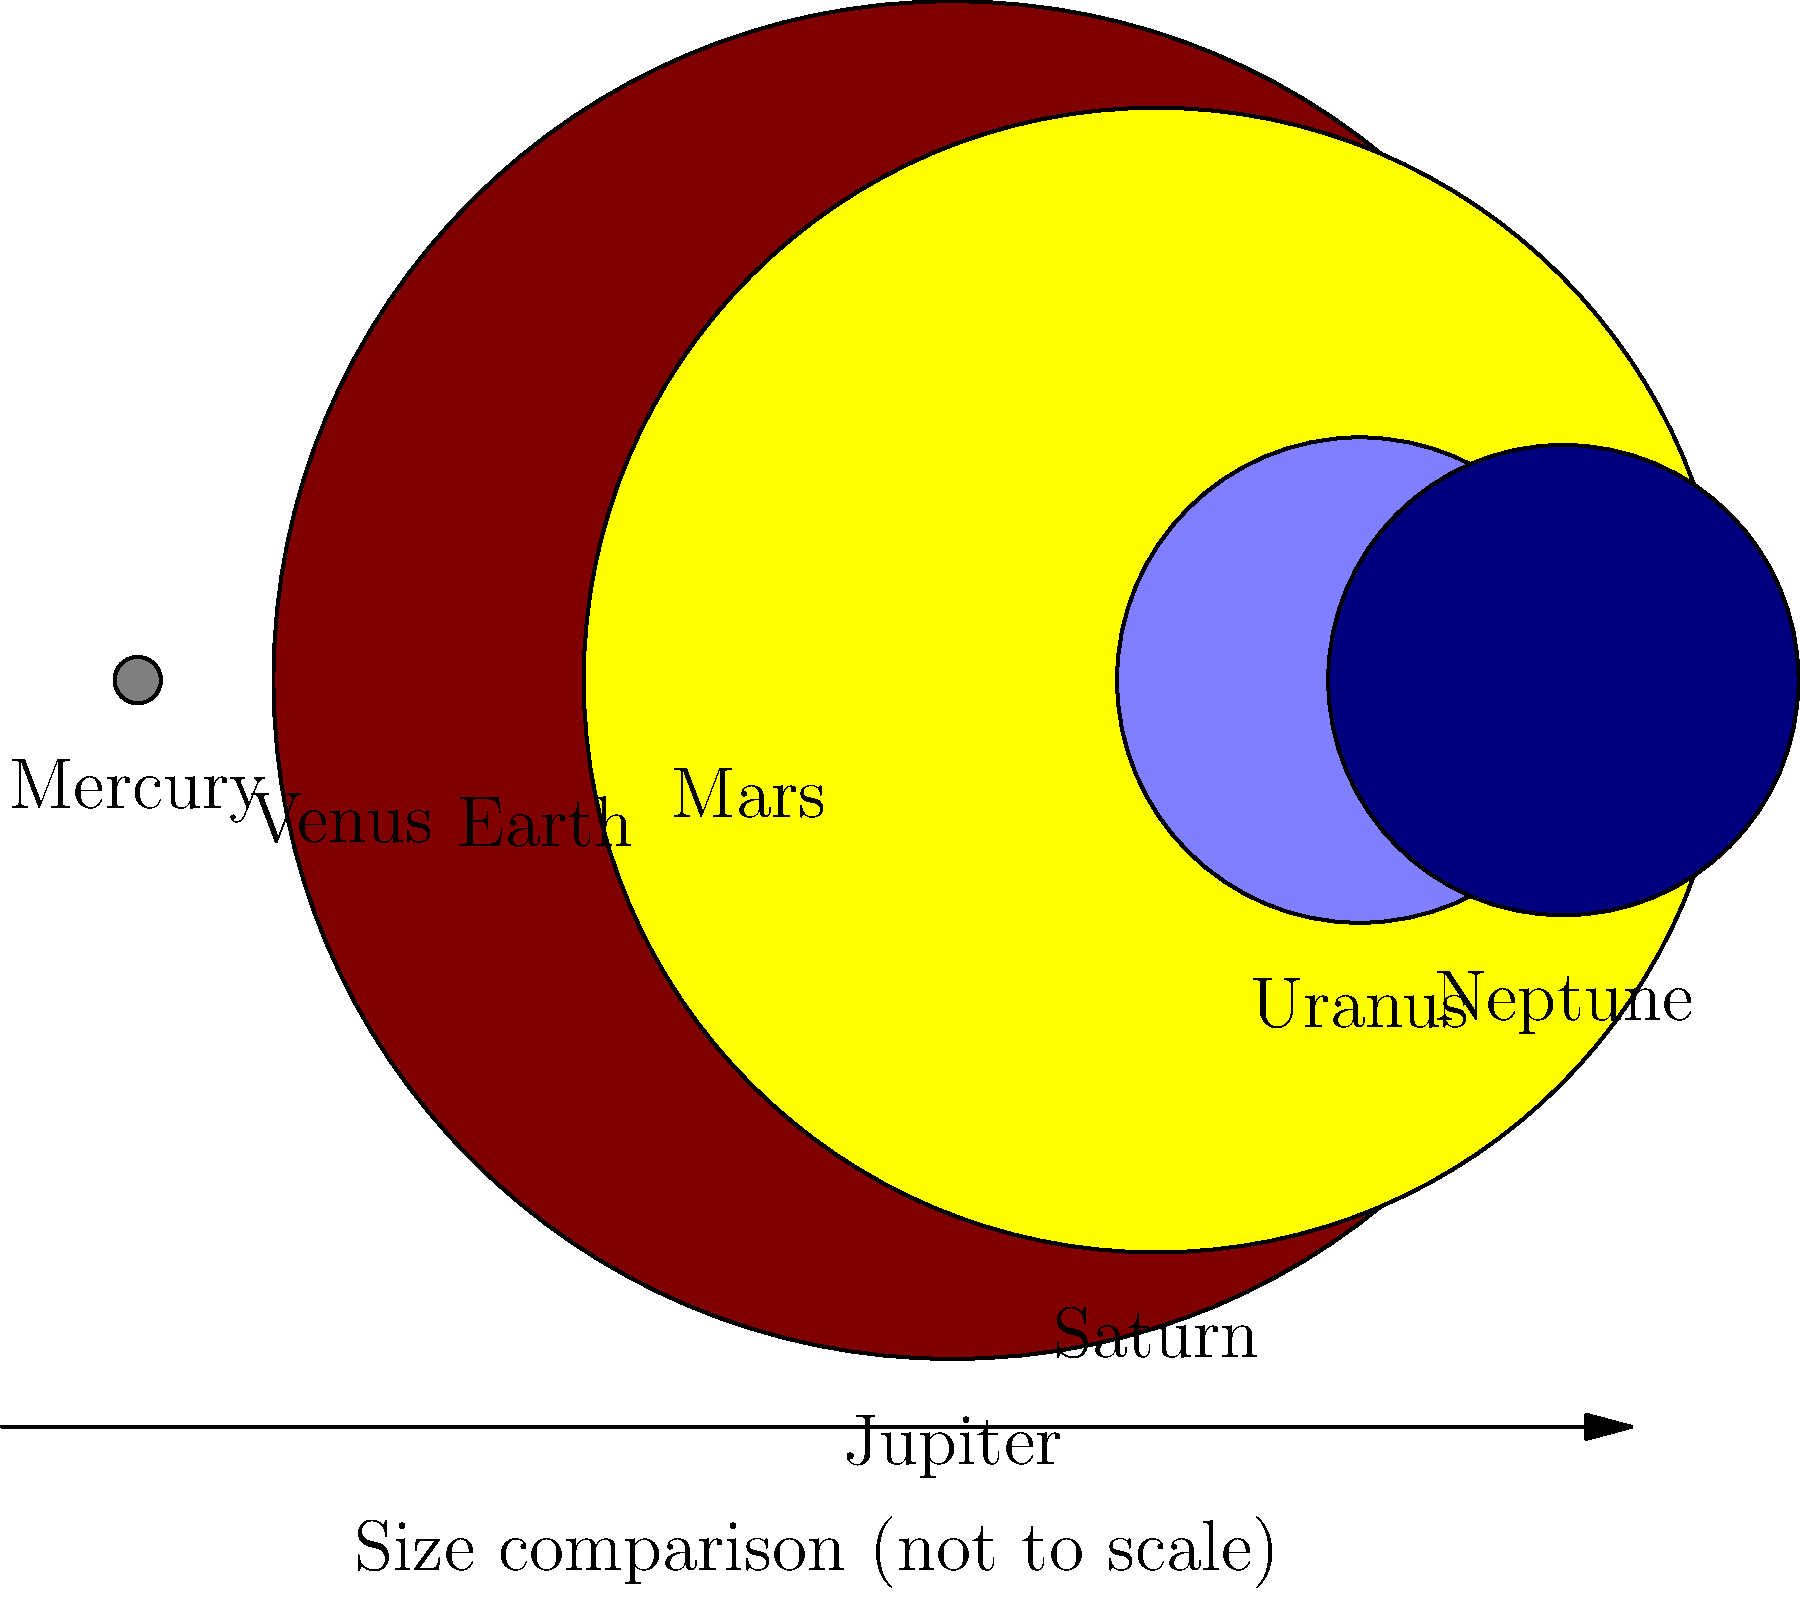In the image above, which planet is represented by the orange circle, and how does its size compare to Earth's? Let's analyze this step-by-step:

1. The image shows a comparison of planet sizes in our solar system.
2. Each planet is represented by a colored circle, with its name below.
3. The orange circle represents Venus.
4. Earth is represented by the blue circle.
5. Comparing the sizes of the orange (Venus) and blue (Earth) circles:
   - They appear very similar in size.
   - Venus is slightly smaller than Earth.
6. In reality:
   - Venus has a diameter of 12,104 km.
   - Earth has a diameter of 12,756 km.
7. Venus is about 95% the size of Earth.

This question relates to celebrity gossip interests as planet sizes can be metaphorically compared to the "sizes" or popularity of celebrities in the entertainment industry, where some stars may appear similar in fame but have subtle differences in their influence or fan base.
Answer: Venus; slightly smaller than Earth 